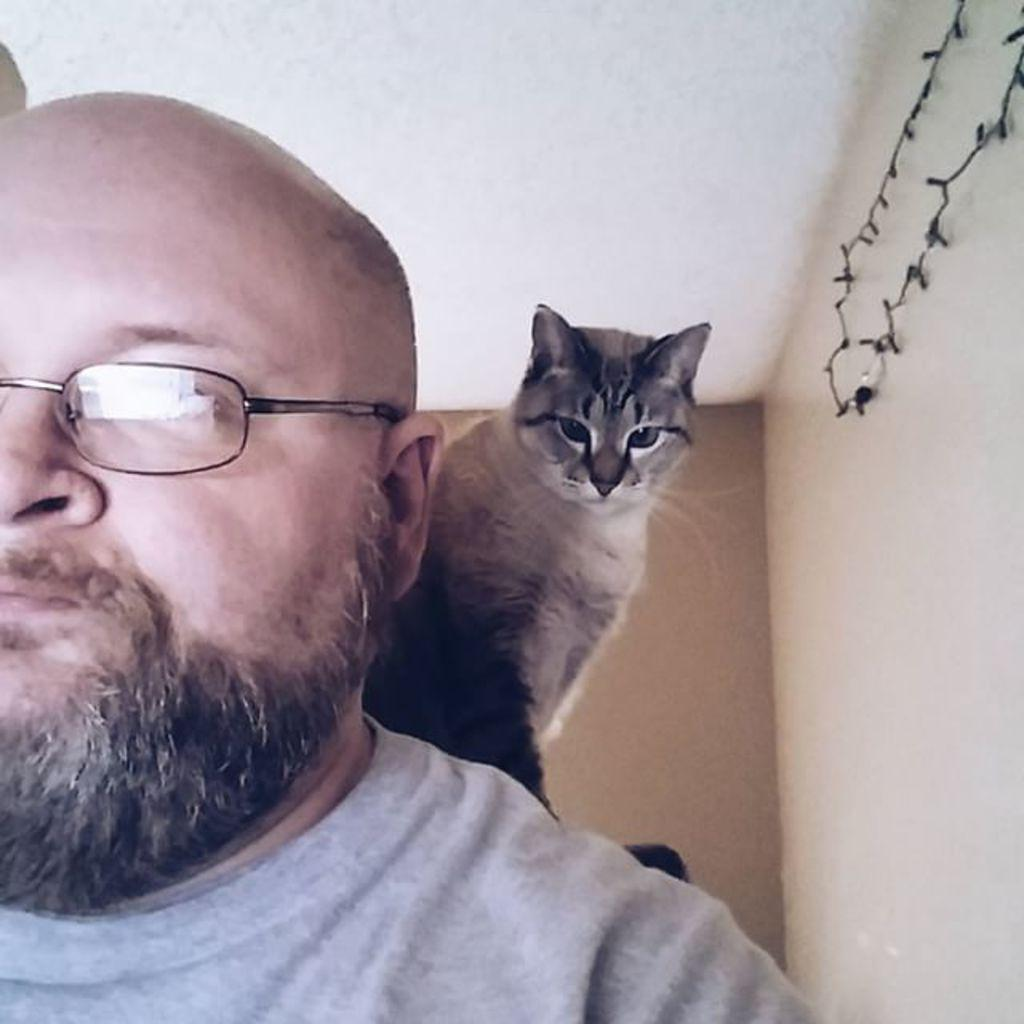Who is present in the image? There is a person in the image. Can you describe the person's appearance? The person has a beard and is wearing a gray color T-shirt. What other living creature is in the image? There is a cat in the image. Where is the cat positioned in relation to the person? The cat is on the person's shoulder. What type of van can be seen parked on the side of the person during their vacation? There is no van or reference to a vacation in the image; it features a person with a cat on their shoulder. 